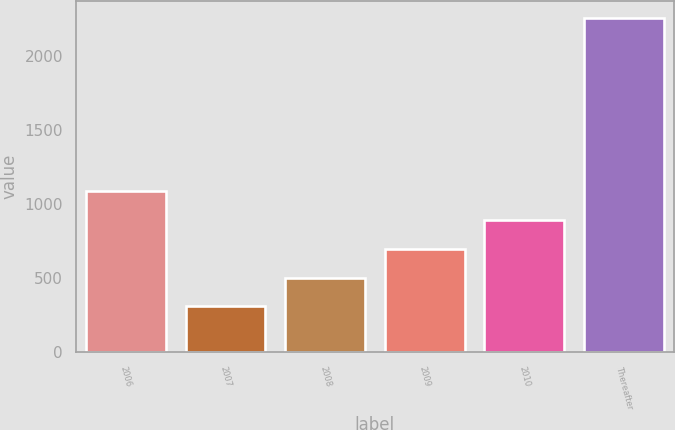Convert chart to OTSL. <chart><loc_0><loc_0><loc_500><loc_500><bar_chart><fcel>2006<fcel>2007<fcel>2008<fcel>2009<fcel>2010<fcel>Thereafter<nl><fcel>1086.8<fcel>308<fcel>502.7<fcel>697.4<fcel>892.1<fcel>2255<nl></chart> 